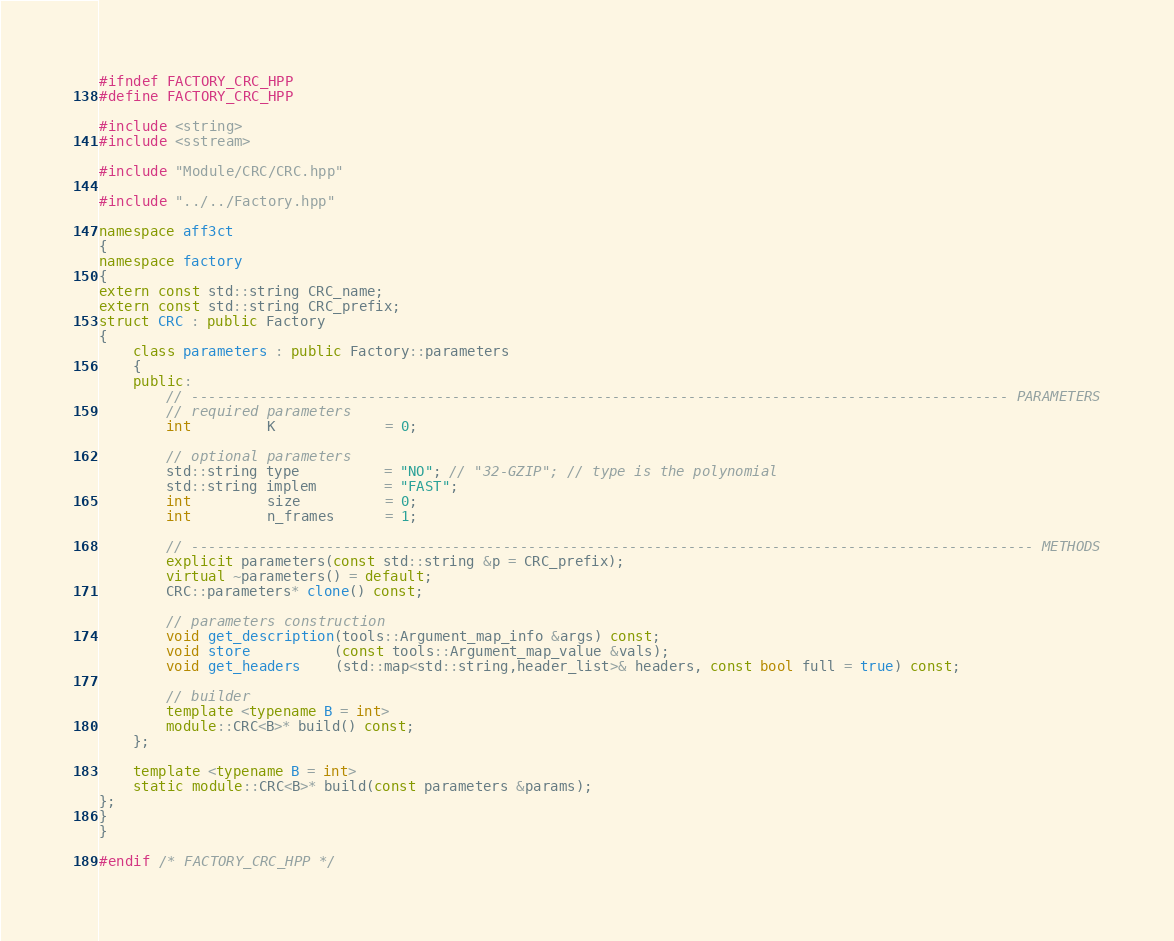Convert code to text. <code><loc_0><loc_0><loc_500><loc_500><_C++_>#ifndef FACTORY_CRC_HPP
#define FACTORY_CRC_HPP

#include <string>
#include <sstream>

#include "Module/CRC/CRC.hpp"

#include "../../Factory.hpp"

namespace aff3ct
{
namespace factory
{
extern const std::string CRC_name;
extern const std::string CRC_prefix;
struct CRC : public Factory
{
	class parameters : public Factory::parameters
	{
	public:
		// ------------------------------------------------------------------------------------------------- PARAMETERS
		// required parameters
		int         K             = 0;

		// optional parameters
		std::string type          = "NO"; // "32-GZIP"; // type is the polynomial
		std::string implem        = "FAST";
		int         size          = 0;
		int         n_frames      = 1;

		// ---------------------------------------------------------------------------------------------------- METHODS
		explicit parameters(const std::string &p = CRC_prefix);
		virtual ~parameters() = default;
		CRC::parameters* clone() const;

		// parameters construction
		void get_description(tools::Argument_map_info &args) const;
		void store          (const tools::Argument_map_value &vals);
		void get_headers    (std::map<std::string,header_list>& headers, const bool full = true) const;

		// builder
		template <typename B = int>
		module::CRC<B>* build() const;
	};

	template <typename B = int>
	static module::CRC<B>* build(const parameters &params);
};
}
}

#endif /* FACTORY_CRC_HPP */
</code> 